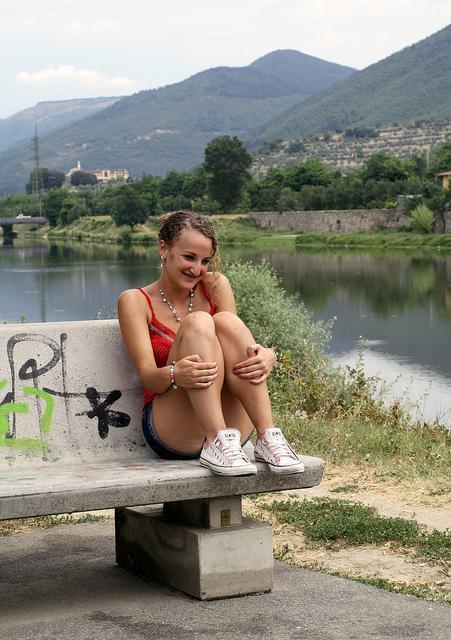How many sandwiches are on the plate?
Give a very brief answer. 0. 